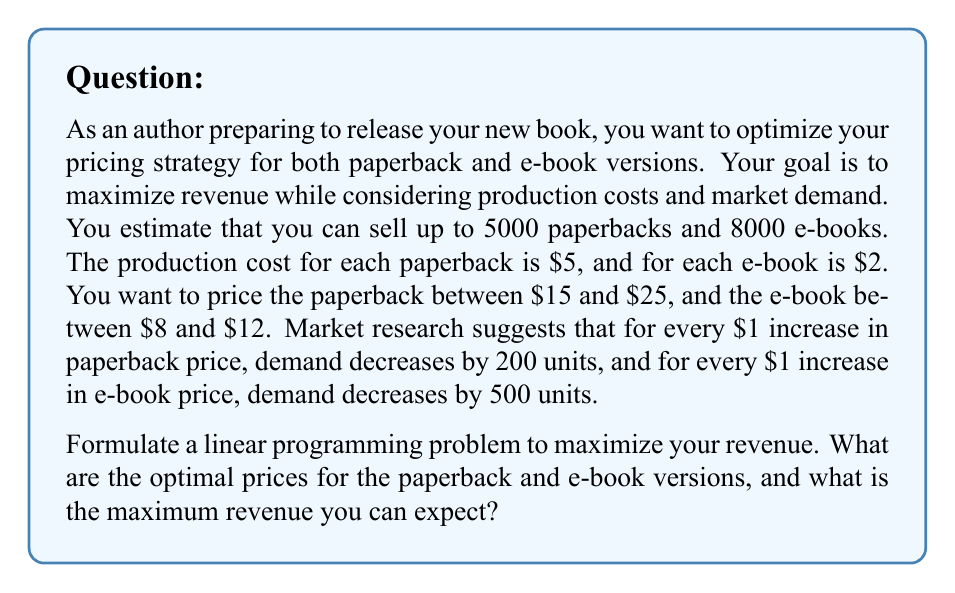Teach me how to tackle this problem. Let's approach this step-by-step:

1) Define variables:
   $x$ = paperback price
   $y$ = e-book price

2) Objective function (Revenue):
   Revenue = (Price - Cost) * Quantity for each version
   Paperback quantity: $5000 - 200(x - 15)$ = $8000 - 200x$
   E-book quantity: $8000 - 500(y - 8)$ = $12000 - 500y$
   
   Revenue = $(x - 5)(8000 - 200x) + (y - 2)(12000 - 500y)$
           = $8000x - 200x^2 - 40000 + 1000x + 12000y - 500y^2 - 24000 + 1000y$
           = $-200x^2 + 9000x - 500y^2 + 13000y - 64000$

3) Constraints:
   $15 \leq x \leq 25$
   $8 \leq y \leq 12$
   $8000 - 200x \geq 0$
   $12000 - 500y \geq 0$

4) This is a quadratic programming problem. To solve it, we can use calculus to find the maximum point within the feasible region.

5) Take partial derivatives and set them to zero:
   $\frac{\partial R}{\partial x} = -400x + 9000 = 0$
   $\frac{\partial R}{\partial y} = -1000y + 13000 = 0$

6) Solve these equations:
   $x = 22.5$
   $y = 13$

7) Check if these values satisfy the constraints:
   $x = 22.5$ is within $[15, 25]$
   $y = 13$ is not within $[8, 12]$, so we need to use the boundary value $y = 12$

8) Recalculate $x$ with $y = 12$:
   $-400x + 9000 = 0$
   $x = 22.5$

9) Final check:
   $22.5$ is within $[15, 25]$
   $8000 - 200(22.5) = 3500 > 0$
   $12000 - 500(12) = 6000 > 0$

10) Calculate the maximum revenue:
    $R = -200(22.5)^2 + 9000(22.5) - 500(12)^2 + 13000(12) - 64000$
    $= -101250 + 202500 - 72000 + 156000 - 64000$
    $= 121250$

Therefore, the optimal prices are $22.5 for the paperback and $12 for the e-book, resulting in a maximum revenue of $121,250.
Answer: Paperback: $22.50, E-book: $12.00, Maximum Revenue: $121,250 